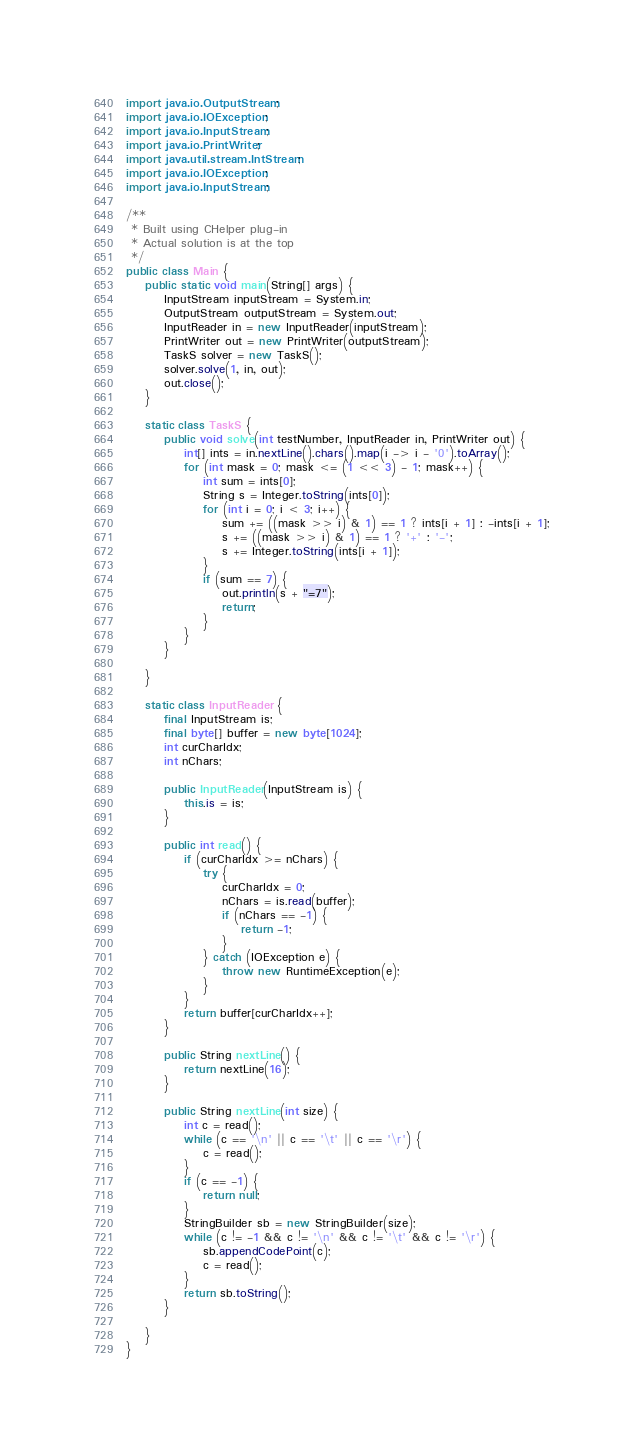Convert code to text. <code><loc_0><loc_0><loc_500><loc_500><_Java_>import java.io.OutputStream;
import java.io.IOException;
import java.io.InputStream;
import java.io.PrintWriter;
import java.util.stream.IntStream;
import java.io.IOException;
import java.io.InputStream;

/**
 * Built using CHelper plug-in
 * Actual solution is at the top
 */
public class Main {
    public static void main(String[] args) {
        InputStream inputStream = System.in;
        OutputStream outputStream = System.out;
        InputReader in = new InputReader(inputStream);
        PrintWriter out = new PrintWriter(outputStream);
        TaskS solver = new TaskS();
        solver.solve(1, in, out);
        out.close();
    }

    static class TaskS {
        public void solve(int testNumber, InputReader in, PrintWriter out) {
            int[] ints = in.nextLine().chars().map(i -> i - '0').toArray();
            for (int mask = 0; mask <= (1 << 3) - 1; mask++) {
                int sum = ints[0];
                String s = Integer.toString(ints[0]);
                for (int i = 0; i < 3; i++) {
                    sum += ((mask >> i) & 1) == 1 ? ints[i + 1] : -ints[i + 1];
                    s += ((mask >> i) & 1) == 1 ? '+' : '-';
                    s += Integer.toString(ints[i + 1]);
                }
                if (sum == 7) {
                    out.println(s + "=7");
                    return;
                }
            }
        }

    }

    static class InputReader {
        final InputStream is;
        final byte[] buffer = new byte[1024];
        int curCharIdx;
        int nChars;

        public InputReader(InputStream is) {
            this.is = is;
        }

        public int read() {
            if (curCharIdx >= nChars) {
                try {
                    curCharIdx = 0;
                    nChars = is.read(buffer);
                    if (nChars == -1) {
                        return -1;
                    }
                } catch (IOException e) {
                    throw new RuntimeException(e);
                }
            }
            return buffer[curCharIdx++];
        }

        public String nextLine() {
            return nextLine(16);
        }

        public String nextLine(int size) {
            int c = read();
            while (c == '\n' || c == '\t' || c == '\r') {
                c = read();
            }
            if (c == -1) {
                return null;
            }
            StringBuilder sb = new StringBuilder(size);
            while (c != -1 && c != '\n' && c != '\t' && c != '\r') {
                sb.appendCodePoint(c);
                c = read();
            }
            return sb.toString();
        }

    }
}

</code> 